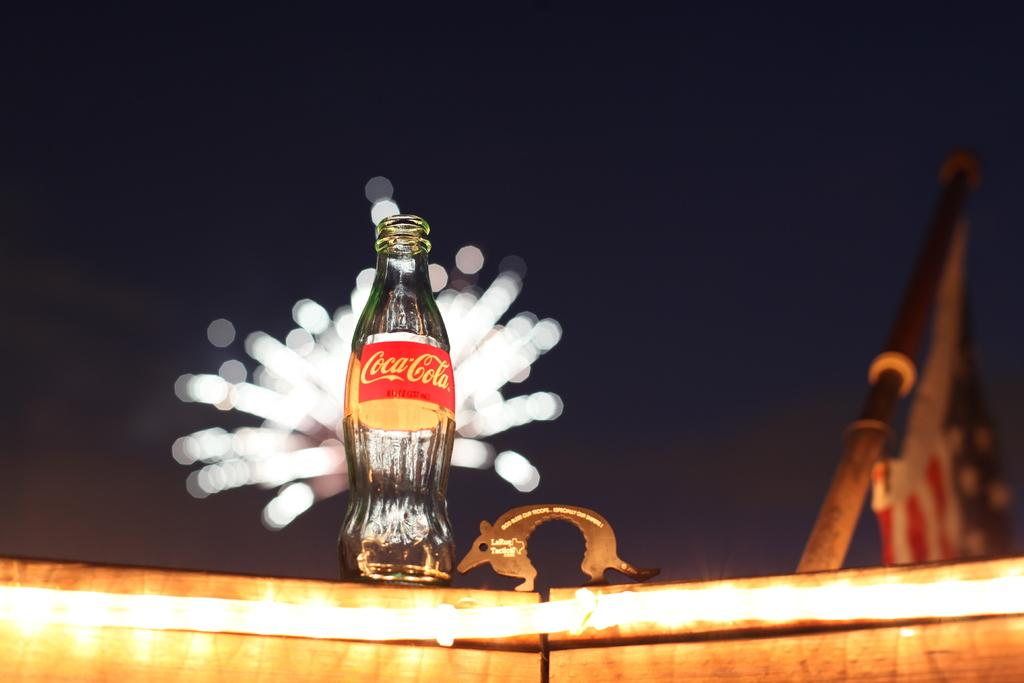What type of container is visible in the image? There is a glass bottle in the image. What is written on the glass bottle? The glass bottle has "Coca Cola" written on it. What color is the silver question mark in the image? There is no silver question mark present in the image. 